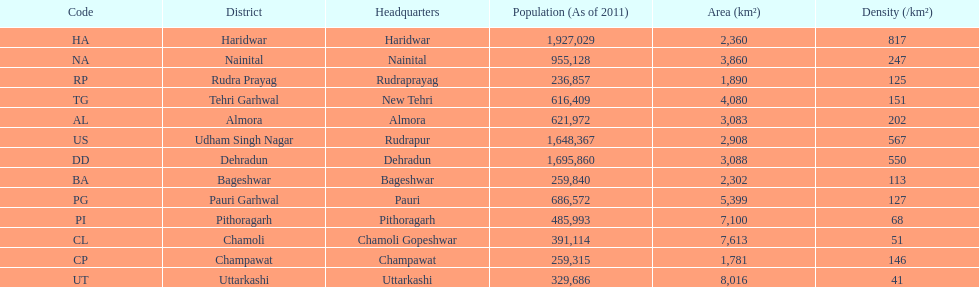How many total districts are there in this area? 13. 